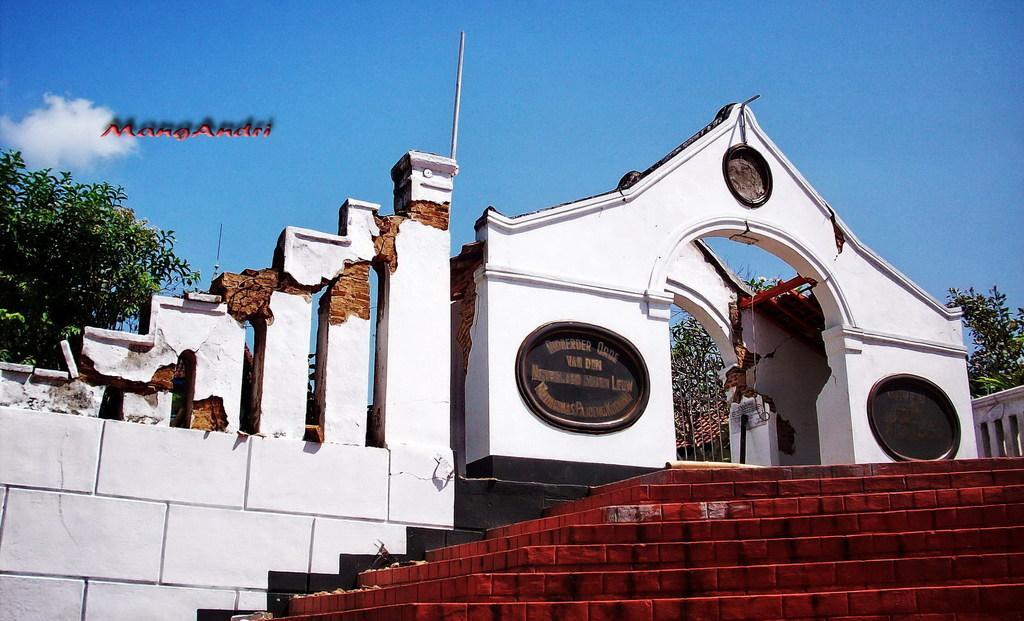Could you give a brief overview of what you see in this image? In the picture I can see collapsed building, stares and some trees. 